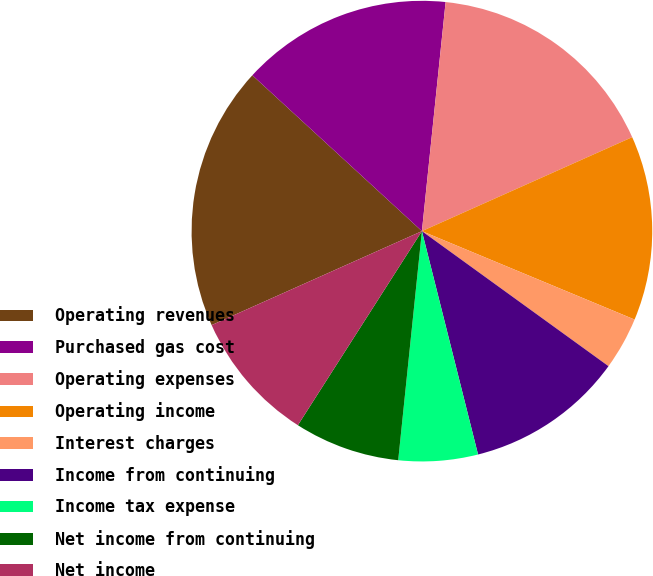Convert chart. <chart><loc_0><loc_0><loc_500><loc_500><pie_chart><fcel>Operating revenues<fcel>Purchased gas cost<fcel>Operating expenses<fcel>Operating income<fcel>Interest charges<fcel>Income from continuing<fcel>Income tax expense<fcel>Net income from continuing<fcel>Net income<fcel>Diluted net income from<nl><fcel>18.52%<fcel>14.81%<fcel>16.67%<fcel>12.96%<fcel>3.7%<fcel>11.11%<fcel>5.56%<fcel>7.41%<fcel>9.26%<fcel>0.0%<nl></chart> 